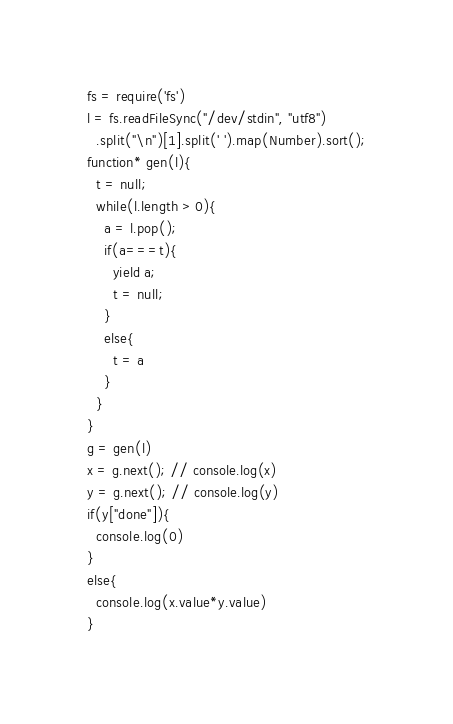<code> <loc_0><loc_0><loc_500><loc_500><_JavaScript_>fs = require('fs')
l = fs.readFileSync("/dev/stdin", "utf8")
  .split("\n")[1].split(' ').map(Number).sort();
function* gen(l){
  t = null;
  while(l.length > 0){
    a = l.pop();
    if(a===t){
      yield a;
      t = null;
    }
    else{
      t = a
    }
  }
}
g = gen(l)
x = g.next(); // console.log(x)
y = g.next(); // console.log(y)
if(y["done"]){
  console.log(0)
}
else{
  console.log(x.value*y.value)
}</code> 